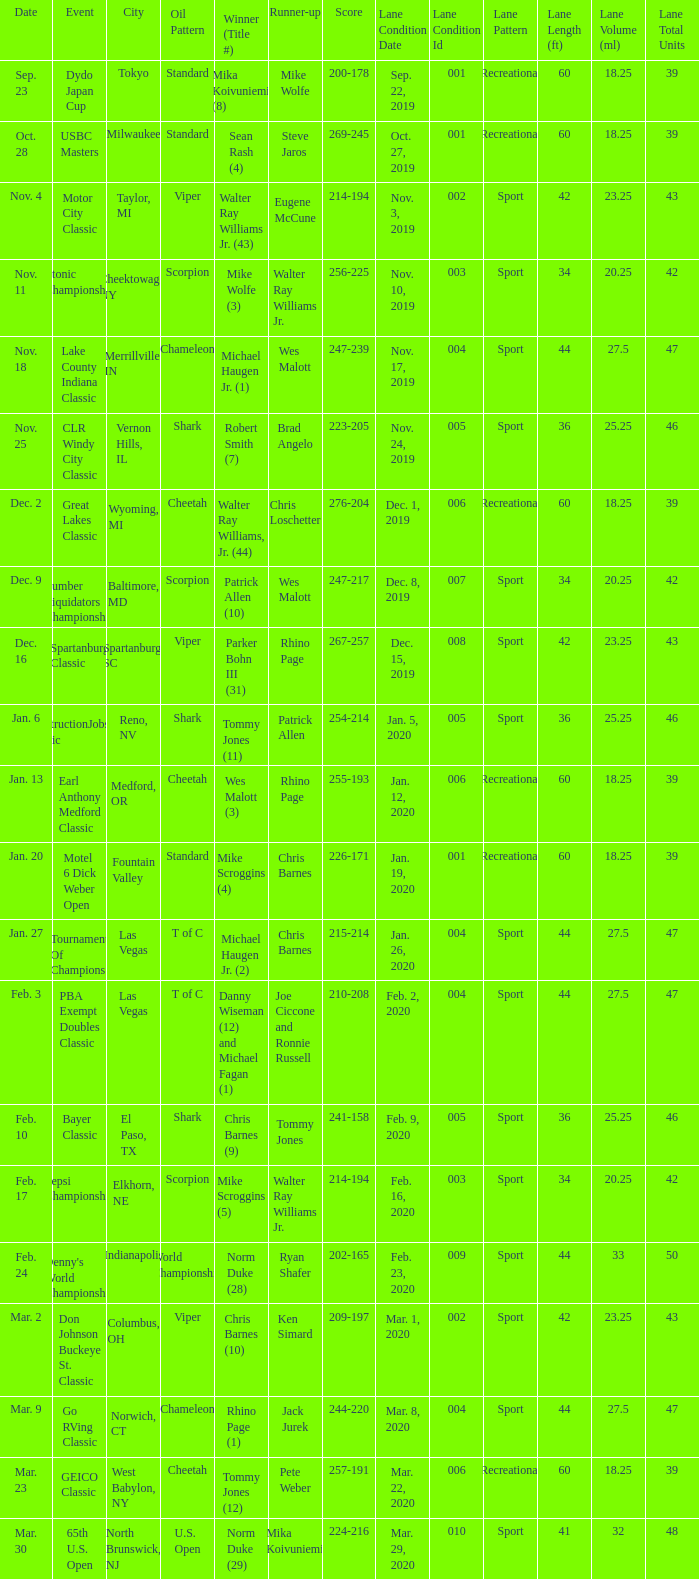Name the Event which has a Score of 209-197? Don Johnson Buckeye St. Classic. 